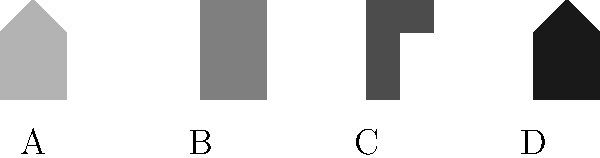As a superstitious fan, you believe that certain magic tricks cause more fear for the comedian, potentially enhancing their performance. Based on the silhouettes of magic tricks shown above, which one do you think would cause the most fear for the comedian, potentially leading to the most thrilling performance? To answer this question, we need to analyze each silhouette and consider which trick might be the most fear-inducing for a comedian:

1. Silhouette A: This appears to be a rabbit-in-hat trick, which is generally considered harmless and unlikely to cause fear.

2. Silhouette B: This resembles a sawing-in-half illusion, which involves apparent danger and could be fear-inducing.

3. Silhouette C: This looks like a levitation trick, which might cause some anxiety but is generally not considered extremely dangerous.

4. Silhouette D: This silhouette suggests an escape trick, possibly from a straightjacket or chains, which can be perceived as dangerous and fear-inducing.

Considering the potential for danger and the psychological impact, the sawing-in-half illusion (B) and the escape trick (D) are likely to cause the most fear. However, the escape trick often involves more physical strain and potential for actual danger, which could lead to a more intense fear response.

Therefore, silhouette D, representing the escape trick, is likely to cause the most fear for the comedian, potentially resulting in the most thrilling performance for a superstitious fan who believes in the connection between the comedian's fear and the excitement of the show.
Answer: D (Escape trick) 